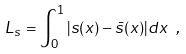<formula> <loc_0><loc_0><loc_500><loc_500>L _ { s } = \int _ { 0 } ^ { 1 } | s ( x ) - \bar { s } ( x ) | d x \ ,</formula> 